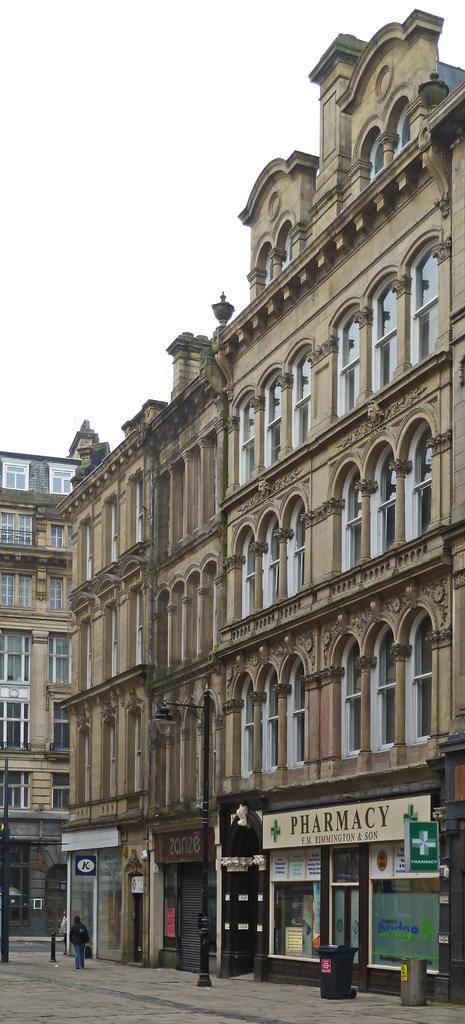Please provide a concise description of this image. In this image we can see there are buildings and stalls and we can see there is a person walking on the pavement. 